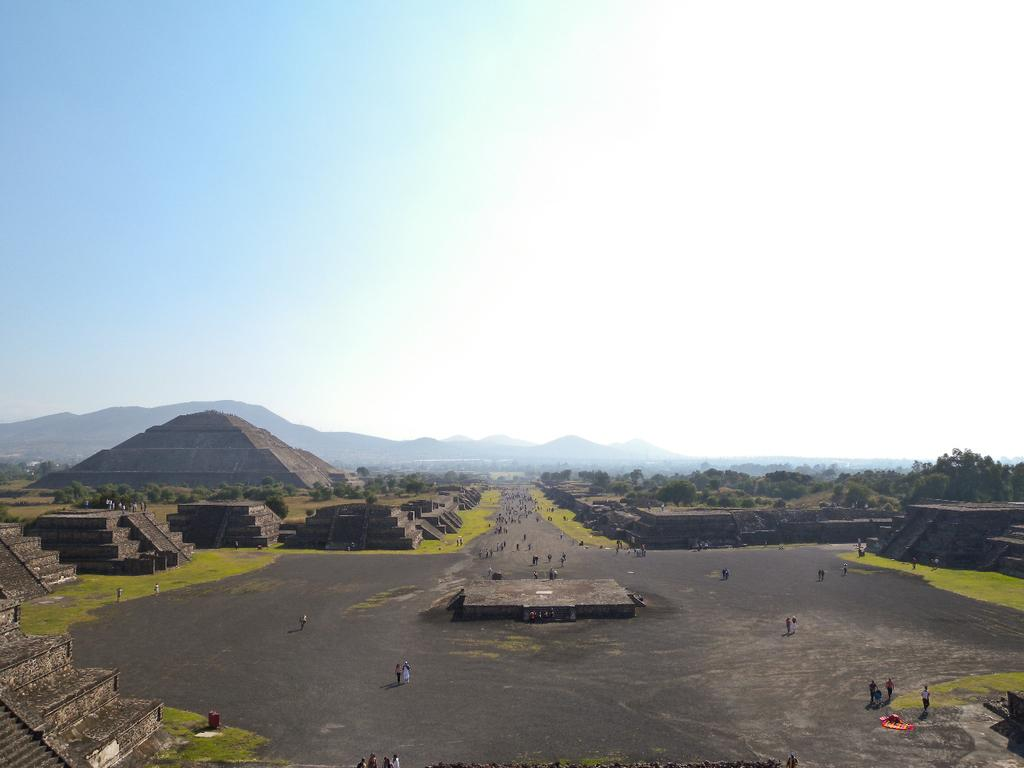What are the people in the image doing? The people in the image are walking on the road. What structures can be seen on both sides of the road? There are pyramids on both the right and left sides of the image. What type of natural elements are visible in the background of the image? There are trees and mountains in the background of the image. What is visible above the trees and mountains in the image? The sky is visible in the background of the image. What type of class is being held in the image? There is no class present in the image; it features people walking on a road with pyramids, trees, mountains, and the sky in the background. 